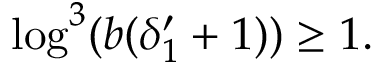Convert formula to latex. <formula><loc_0><loc_0><loc_500><loc_500>\log ^ { 3 } ( b ( \delta _ { 1 } ^ { \prime } + 1 ) ) \geq 1 .</formula> 